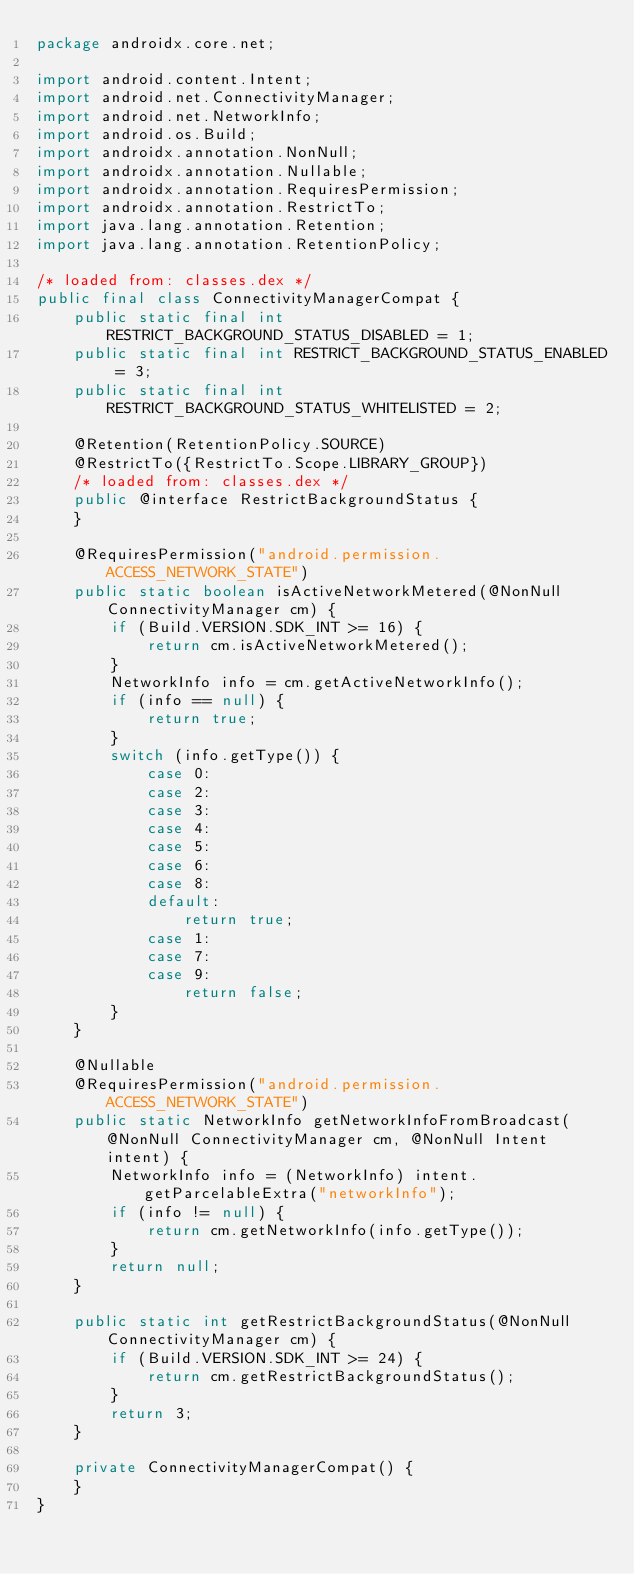<code> <loc_0><loc_0><loc_500><loc_500><_Java_>package androidx.core.net;

import android.content.Intent;
import android.net.ConnectivityManager;
import android.net.NetworkInfo;
import android.os.Build;
import androidx.annotation.NonNull;
import androidx.annotation.Nullable;
import androidx.annotation.RequiresPermission;
import androidx.annotation.RestrictTo;
import java.lang.annotation.Retention;
import java.lang.annotation.RetentionPolicy;

/* loaded from: classes.dex */
public final class ConnectivityManagerCompat {
    public static final int RESTRICT_BACKGROUND_STATUS_DISABLED = 1;
    public static final int RESTRICT_BACKGROUND_STATUS_ENABLED = 3;
    public static final int RESTRICT_BACKGROUND_STATUS_WHITELISTED = 2;

    @Retention(RetentionPolicy.SOURCE)
    @RestrictTo({RestrictTo.Scope.LIBRARY_GROUP})
    /* loaded from: classes.dex */
    public @interface RestrictBackgroundStatus {
    }

    @RequiresPermission("android.permission.ACCESS_NETWORK_STATE")
    public static boolean isActiveNetworkMetered(@NonNull ConnectivityManager cm) {
        if (Build.VERSION.SDK_INT >= 16) {
            return cm.isActiveNetworkMetered();
        }
        NetworkInfo info = cm.getActiveNetworkInfo();
        if (info == null) {
            return true;
        }
        switch (info.getType()) {
            case 0:
            case 2:
            case 3:
            case 4:
            case 5:
            case 6:
            case 8:
            default:
                return true;
            case 1:
            case 7:
            case 9:
                return false;
        }
    }

    @Nullable
    @RequiresPermission("android.permission.ACCESS_NETWORK_STATE")
    public static NetworkInfo getNetworkInfoFromBroadcast(@NonNull ConnectivityManager cm, @NonNull Intent intent) {
        NetworkInfo info = (NetworkInfo) intent.getParcelableExtra("networkInfo");
        if (info != null) {
            return cm.getNetworkInfo(info.getType());
        }
        return null;
    }

    public static int getRestrictBackgroundStatus(@NonNull ConnectivityManager cm) {
        if (Build.VERSION.SDK_INT >= 24) {
            return cm.getRestrictBackgroundStatus();
        }
        return 3;
    }

    private ConnectivityManagerCompat() {
    }
}
</code> 